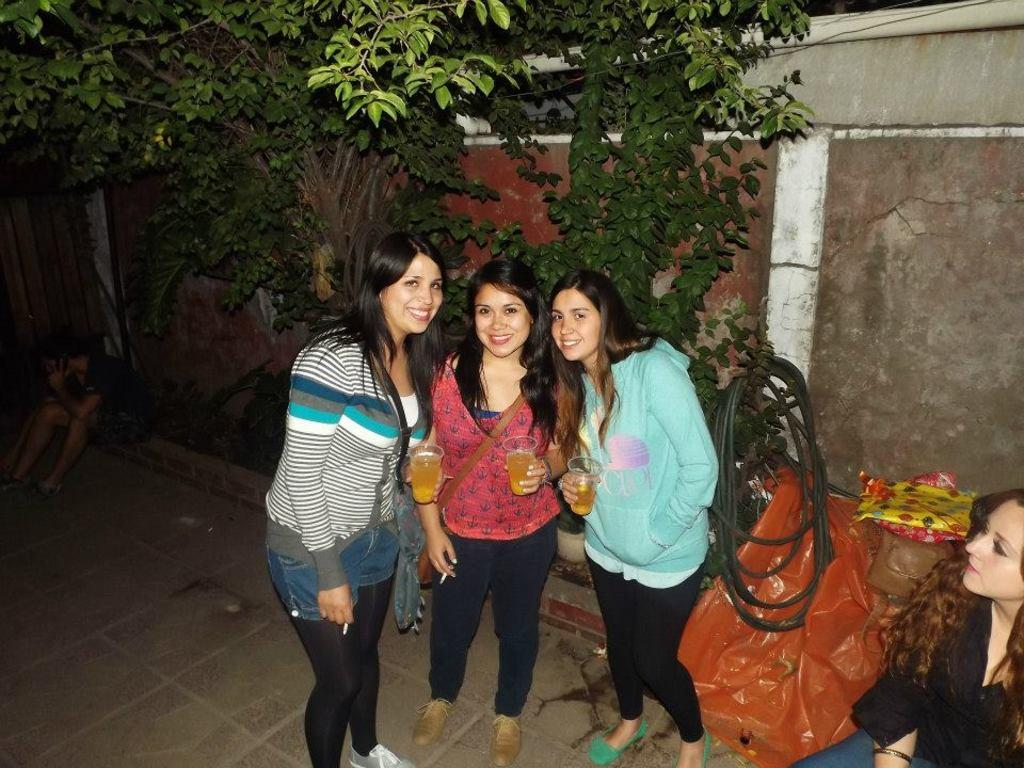How many ladies are in the image? There are three ladies standing in the center of the image. What are the ladies holding in the image? The ladies are holding glasses. What can be seen in the background of the image? There are trees and a wall in the background of the image. What are the people in the image doing? There are people sitting in the image. Can you describe any other objects visible in the image? There is a pipe visible in the image. What type of fuel is being used by the impulse in the image? There is no impulse or fuel present in the image. Can you describe the field where the ladies are standing in the image? There is no field visible in the image; it features three ladies standing in the center, holding glasses, with a background of trees and a wall. 